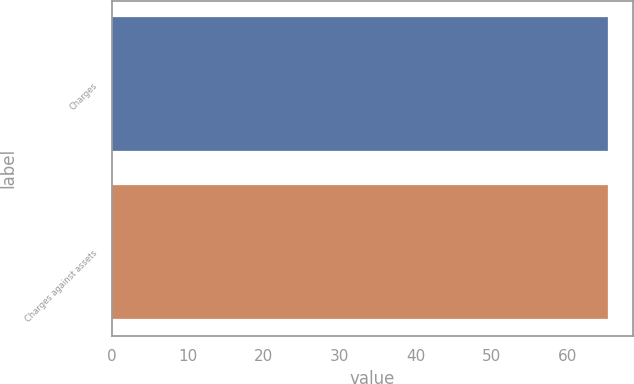Convert chart to OTSL. <chart><loc_0><loc_0><loc_500><loc_500><bar_chart><fcel>Charges<fcel>Charges against assets<nl><fcel>65.3<fcel>65.4<nl></chart> 